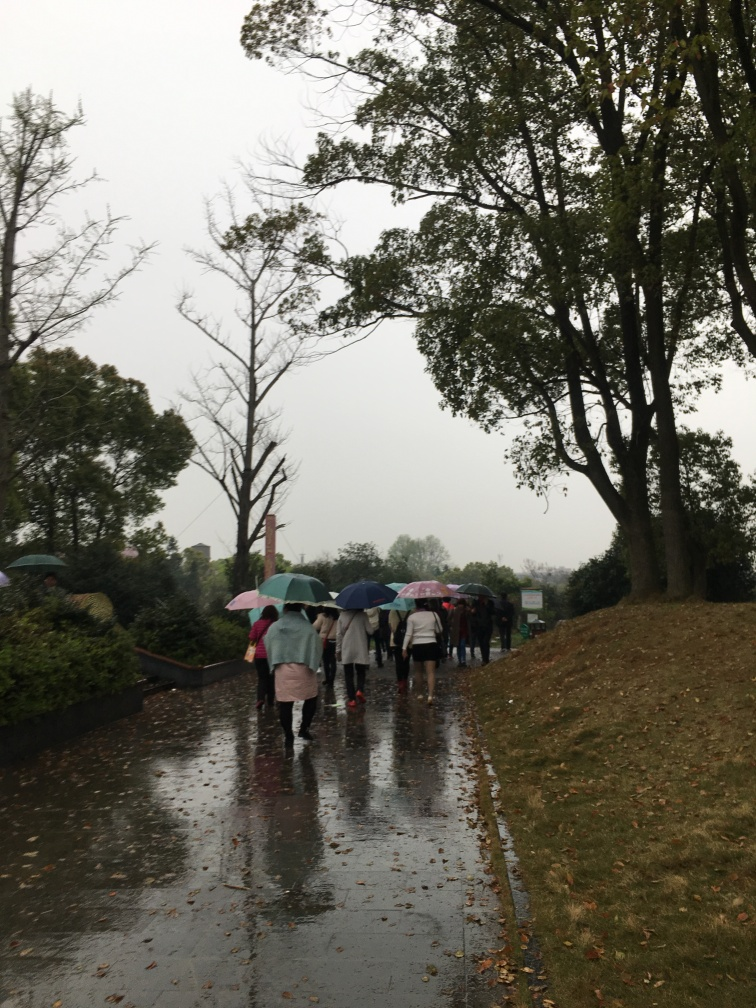How does the weather impact the mood of this image? The grey sky and wet conditions set a somber and introspective mood for the image. The use of umbrellas adds an element of harmony, as the people share a common experience of moving through the rain. The reflections and mirroring on the wet surface add to the contemplative atmosphere. 